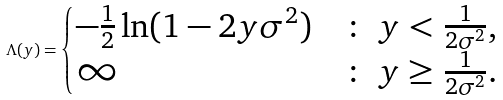Convert formula to latex. <formula><loc_0><loc_0><loc_500><loc_500>\Lambda ( y ) = \begin{cases} - \frac { 1 } { 2 } \ln ( 1 - 2 y \sigma ^ { 2 } ) & \colon \ y < \frac { 1 } { 2 \sigma ^ { 2 } } , \\ \infty & \colon \ y \geq \frac { 1 } { 2 \sigma ^ { 2 } } . \end{cases}</formula> 